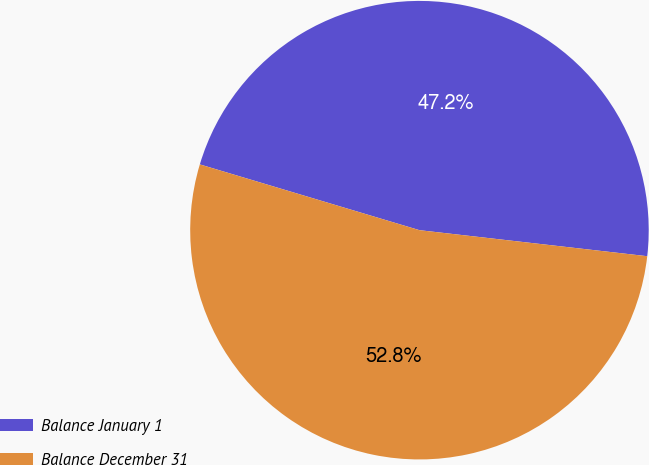Convert chart. <chart><loc_0><loc_0><loc_500><loc_500><pie_chart><fcel>Balance January 1<fcel>Balance December 31<nl><fcel>47.18%<fcel>52.82%<nl></chart> 